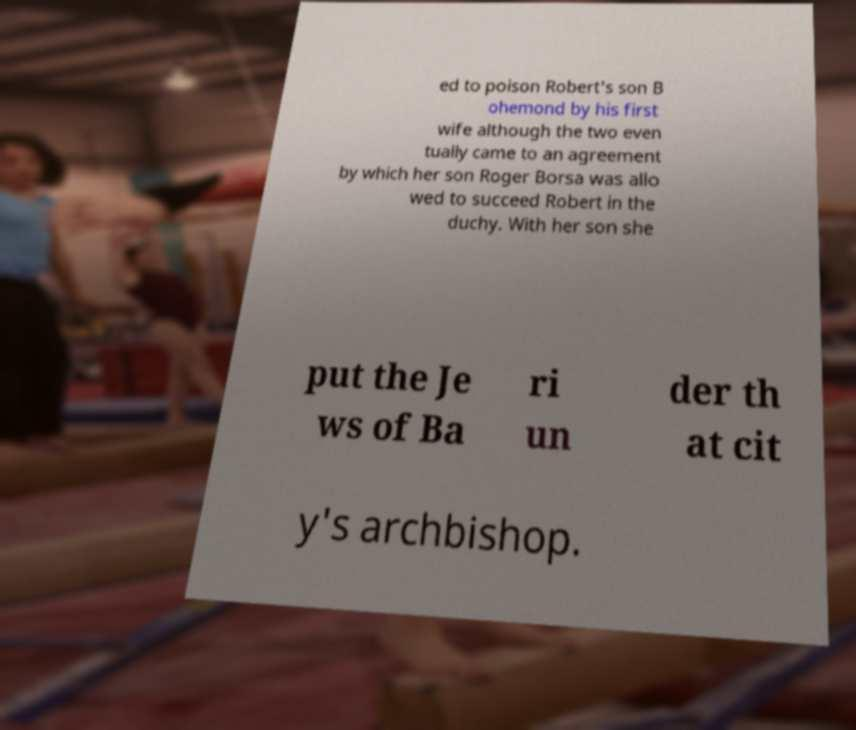For documentation purposes, I need the text within this image transcribed. Could you provide that? ed to poison Robert's son B ohemond by his first wife although the two even tually came to an agreement by which her son Roger Borsa was allo wed to succeed Robert in the duchy. With her son she put the Je ws of Ba ri un der th at cit y's archbishop. 